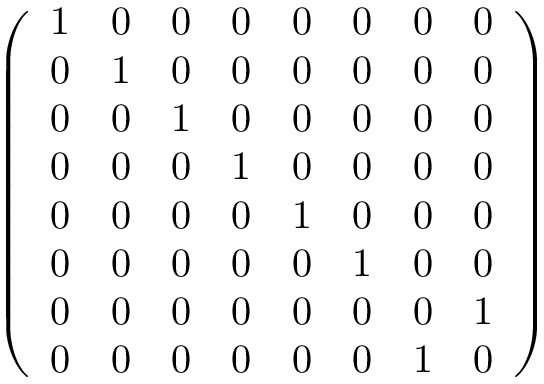Convert formula to latex. <formula><loc_0><loc_0><loc_500><loc_500>\left ( \begin{array} { l l l l l l l l } { 1 } & { 0 } & { 0 } & { 0 } & { 0 } & { 0 } & { 0 } & { 0 } \\ { 0 } & { 1 } & { 0 } & { 0 } & { 0 } & { 0 } & { 0 } & { 0 } \\ { 0 } & { 0 } & { 1 } & { 0 } & { 0 } & { 0 } & { 0 } & { 0 } \\ { 0 } & { 0 } & { 0 } & { 1 } & { 0 } & { 0 } & { 0 } & { 0 } \\ { 0 } & { 0 } & { 0 } & { 0 } & { 1 } & { 0 } & { 0 } & { 0 } \\ { 0 } & { 0 } & { 0 } & { 0 } & { 0 } & { 1 } & { 0 } & { 0 } \\ { 0 } & { 0 } & { 0 } & { 0 } & { 0 } & { 0 } & { 0 } & { 1 } \\ { 0 } & { 0 } & { 0 } & { 0 } & { 0 } & { 0 } & { 1 } & { 0 } \end{array} \right )</formula> 